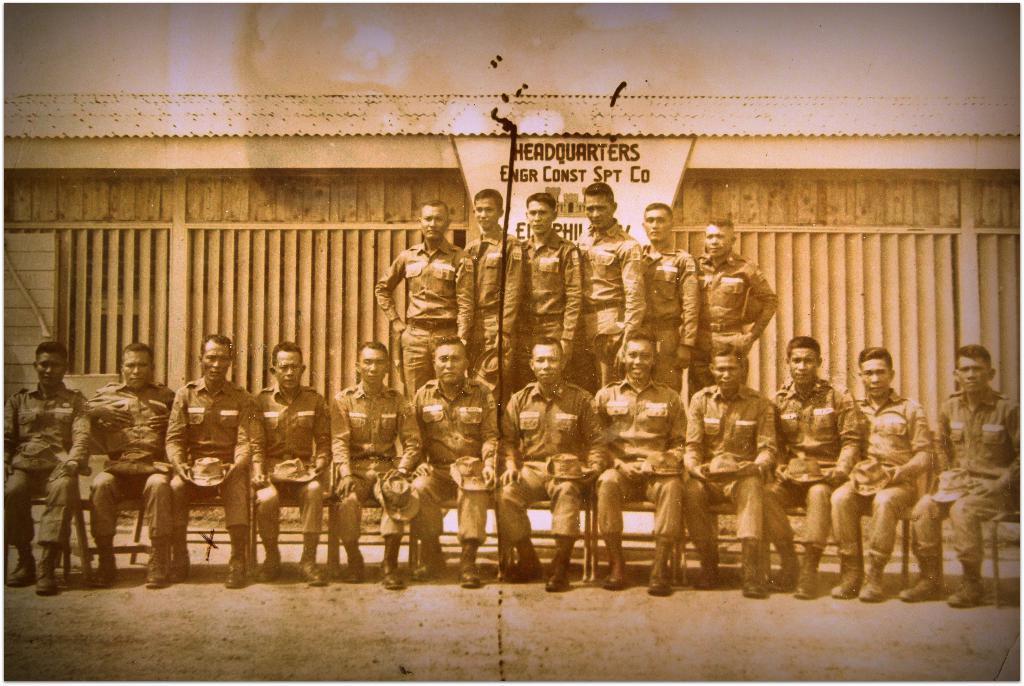Describe this image in one or two sentences. In the image I can see a people sitting and standing and behind there is a board on which there is something written. 